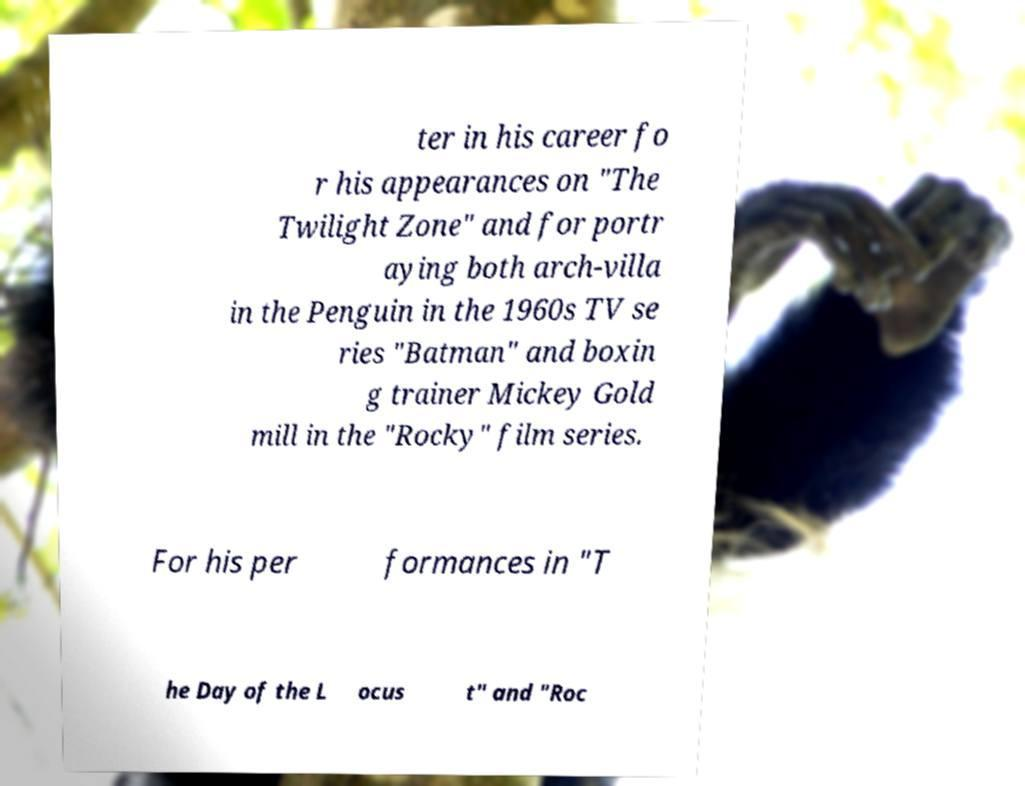What messages or text are displayed in this image? I need them in a readable, typed format. ter in his career fo r his appearances on "The Twilight Zone" and for portr aying both arch-villa in the Penguin in the 1960s TV se ries "Batman" and boxin g trainer Mickey Gold mill in the "Rocky" film series. For his per formances in "T he Day of the L ocus t" and "Roc 